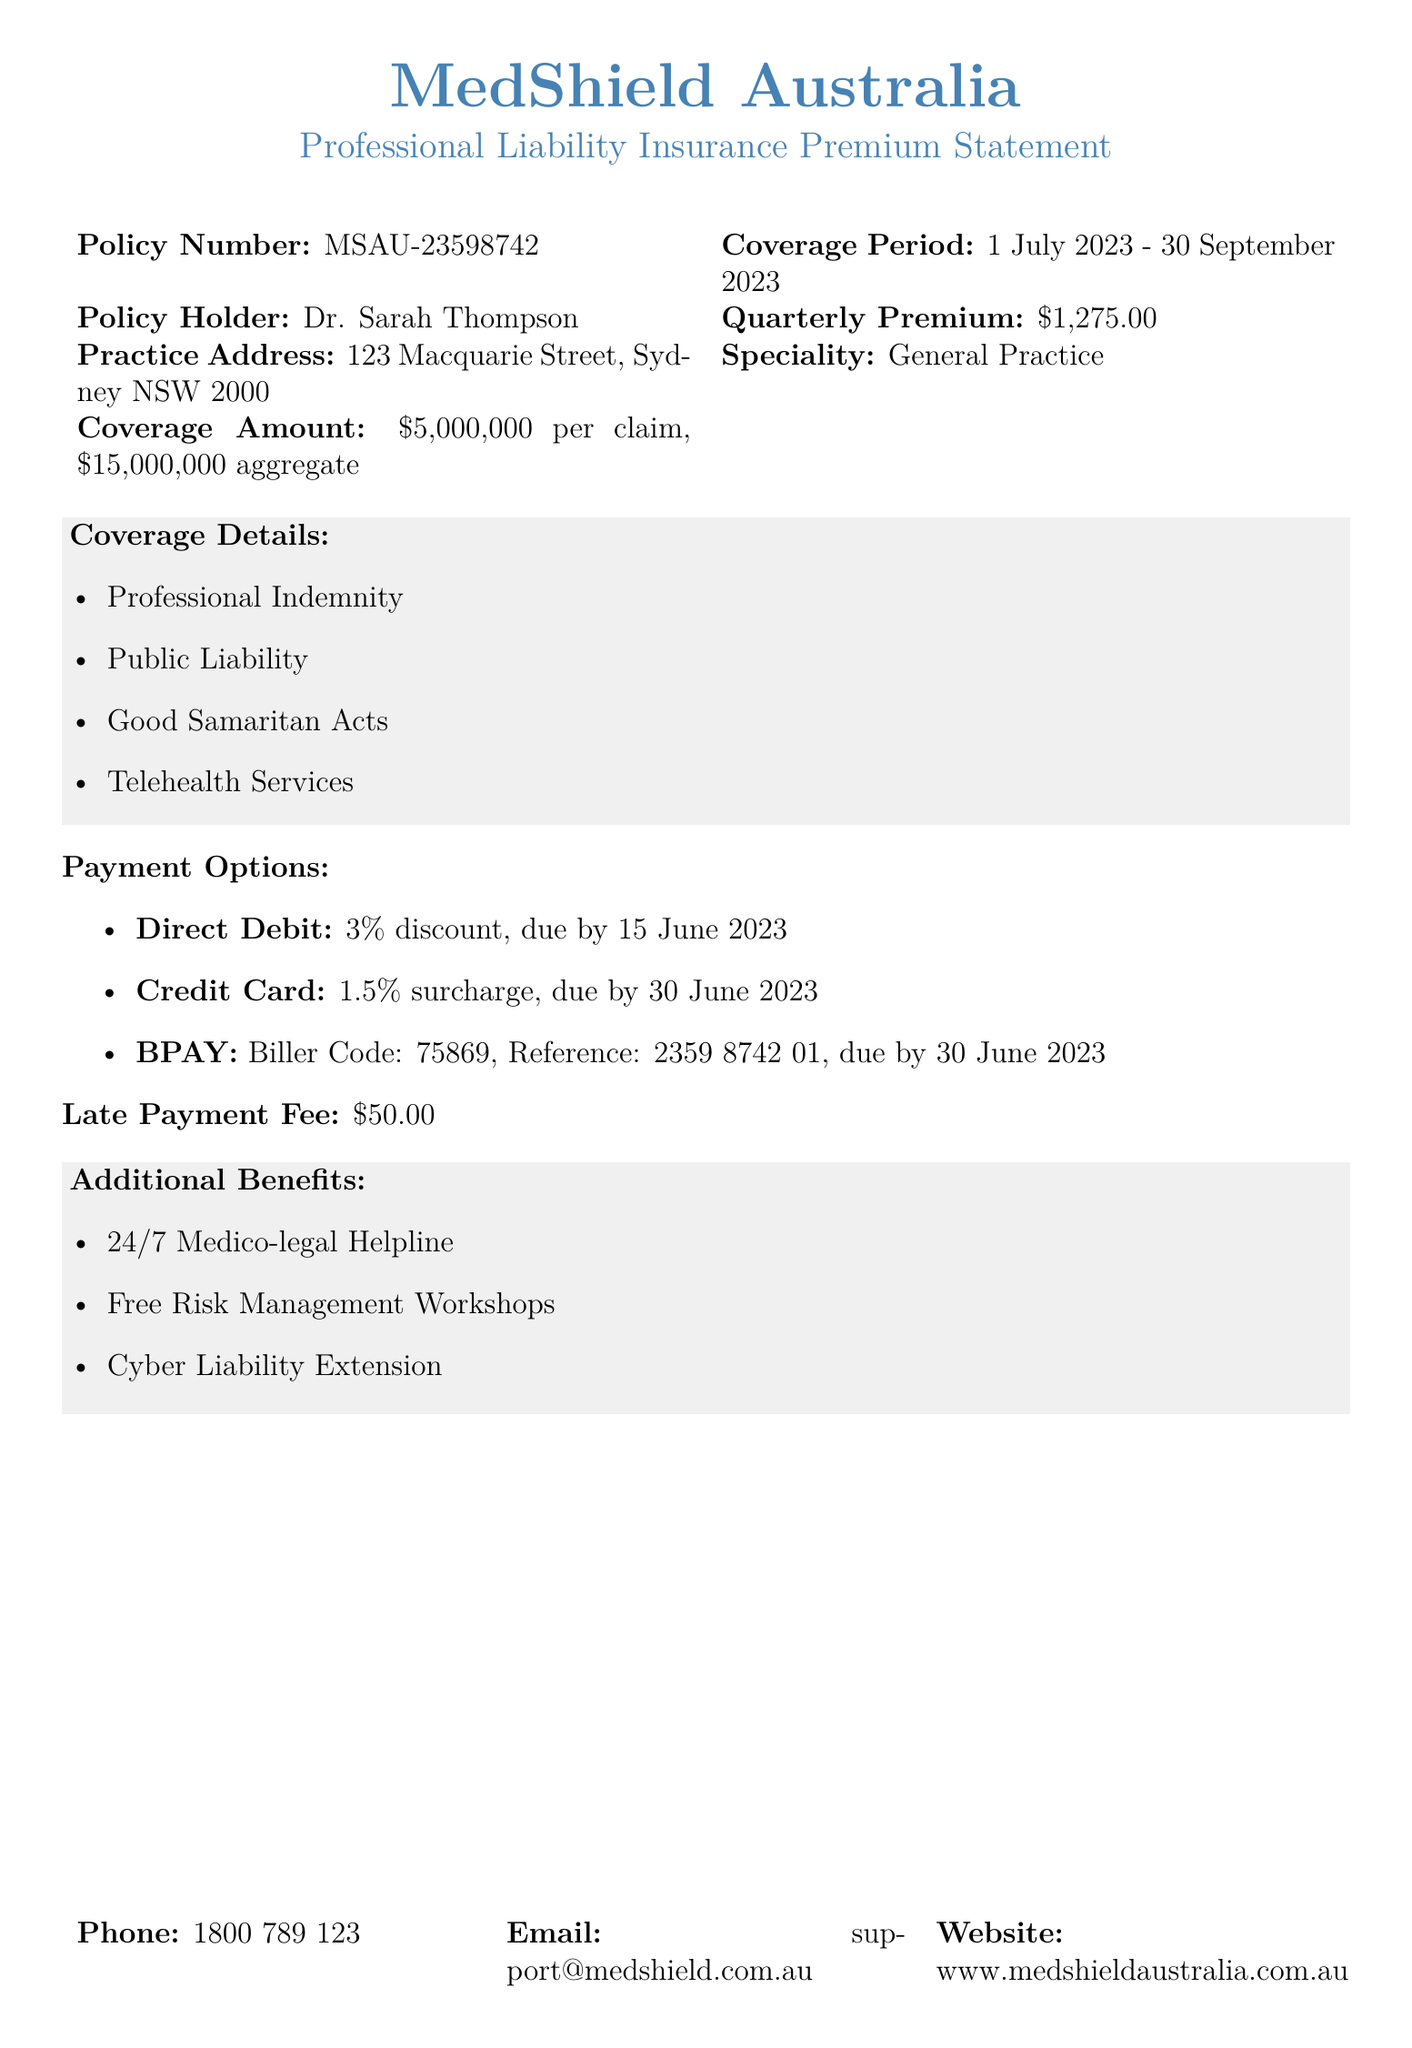What is the policy number? The policy number is listed in the document and is specific to the insurance statement.
Answer: MSAU-23598742 What is the coverage period? The coverage period indicates the time frame during which the insurance applies, as specified in the document.
Answer: 1 July 2023 - 30 September 2023 What is the quarterly premium amount? The quarterly premium amount is the fee due for the insurance coverage as stated in the document.
Answer: $1,275.00 What is the total coverage amount per claim? The coverage amount per claim is a specific limit set for claims under the insurance policy mentioned in the document.
Answer: $5,000,000 What discount is offered for direct debit payment? The document specifies a discount for choosing a direct debit payment method.
Answer: 3% discount What is the late payment fee? A late payment fee is specified in the document for payments made after the due date.
Answer: $50.00 What additional benefit includes support available all the time? The additional benefits section lists services provided to policyholders, including one that offers round-the-clock assistance.
Answer: 24/7 Medico-legal Helpline What payment option incurs a surcharge? The document outlines various payment options and specifies one that comes with an additional charge.
Answer: Credit Card 